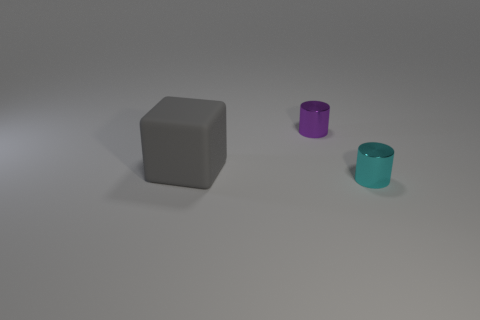There is a cylinder that is left of the cyan shiny object; does it have the same size as the gray thing that is behind the tiny cyan thing?
Your response must be concise. No. There is a gray rubber object behind the cyan cylinder; what shape is it?
Your answer should be very brief. Cube. The cylinder that is on the left side of the small object that is in front of the tiny purple cylinder is made of what material?
Make the answer very short. Metal. Are there any other big blocks of the same color as the big rubber cube?
Your answer should be very brief. No. Does the gray rubber object have the same size as the object that is on the right side of the tiny purple object?
Your answer should be compact. No. How many metal cylinders are to the right of the tiny purple object on the left side of the cylinder that is on the right side of the tiny purple object?
Your answer should be very brief. 1. There is a big gray object; how many small cyan things are right of it?
Offer a very short reply. 1. There is a big block on the left side of the tiny cylinder behind the gray rubber object; what is its color?
Provide a succinct answer. Gray. How many other objects are there of the same material as the cyan cylinder?
Your answer should be compact. 1. Is the number of large gray blocks that are behind the purple object the same as the number of big red shiny things?
Your answer should be compact. Yes. 